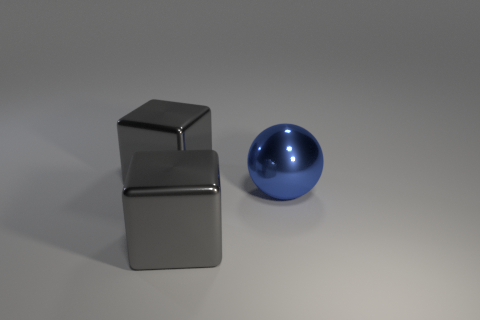What number of objects are cyan rubber cylinders or metallic objects that are behind the metallic sphere?
Ensure brevity in your answer.  1. Is there a big yellow thing of the same shape as the large blue thing?
Your response must be concise. No. What size is the gray cube that is behind the big thing in front of the large sphere?
Provide a short and direct response. Large. What number of metal objects are large gray cubes or small blue cylinders?
Your answer should be very brief. 2. What number of large gray shiny cubes are there?
Offer a very short reply. 2. Do the object in front of the ball and the block behind the metal sphere have the same material?
Offer a terse response. Yes. What material is the big gray thing that is on the right side of the large gray metal object that is behind the sphere?
Provide a succinct answer. Metal. Do the metal object that is behind the large sphere and the gray object in front of the big blue shiny thing have the same shape?
Keep it short and to the point. Yes. What number of other things are there of the same color as the large metal sphere?
Keep it short and to the point. 0. Is there anything else that is the same shape as the blue object?
Give a very brief answer. No. 